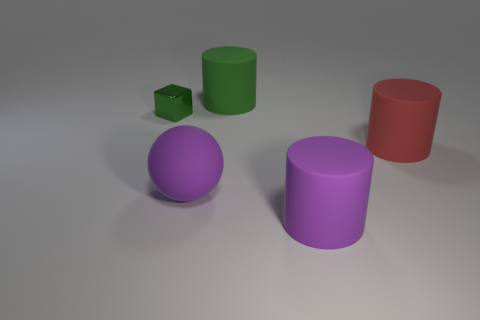Add 2 cyan matte spheres. How many objects exist? 7 Subtract all blocks. How many objects are left? 4 Add 2 green metallic blocks. How many green metallic blocks exist? 3 Subtract 0 yellow blocks. How many objects are left? 5 Subtract all tiny things. Subtract all shiny things. How many objects are left? 3 Add 4 green objects. How many green objects are left? 6 